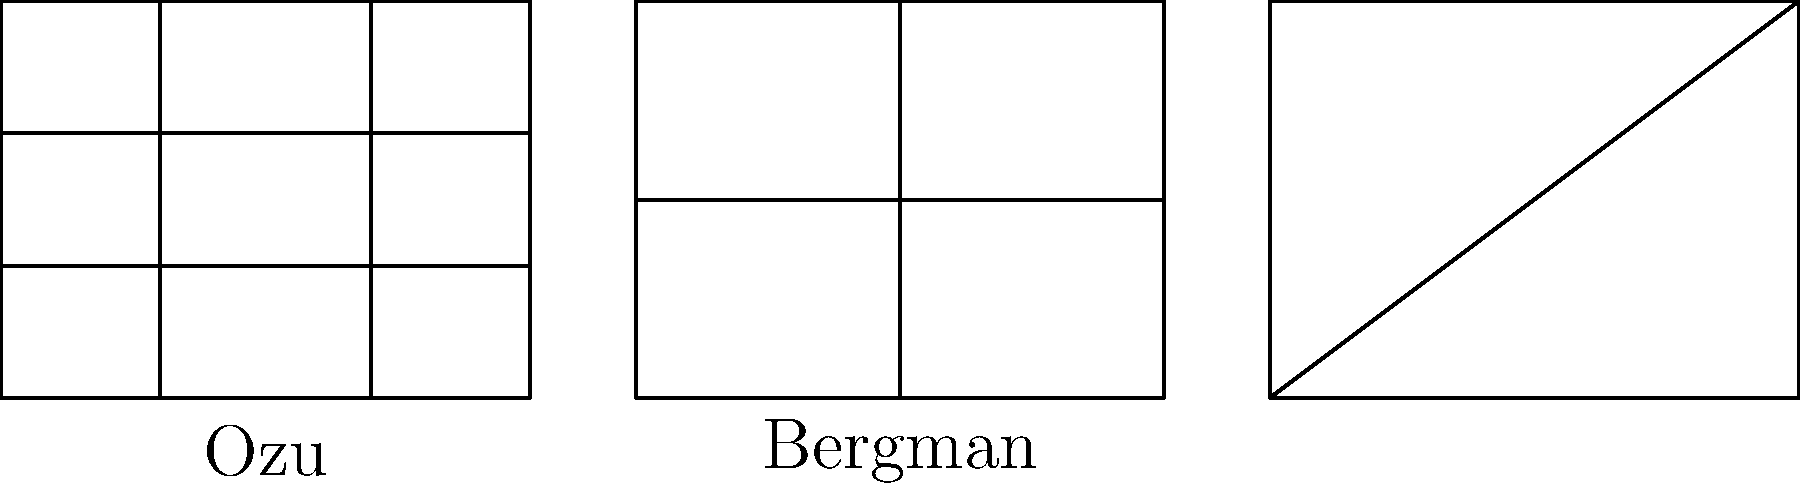Analyze the frame compositions illustrated above, which represent the distinctive styles of three influential foreign directors. Which director is known for using a "tatami shot" perspective, often dividing the frame into precise geometric sections as shown in the first diagram? To answer this question, let's break down the characteristics of each frame composition:

1. The first frame is divided into a 3x3 grid, creating nine equal sections. This precise geometric division is characteristic of the "tatami shot" perspective, named after the traditional Japanese floor mats. This style is strongly associated with Yasujirō Ozu, a renowned Japanese director.

2. The second frame is divided into two vertical sections and two horizontal sections, creating a more balanced and symmetrical composition. This style is often used by Ingmar Bergman, a Swedish director known for his focus on psychological and existential themes.

3. The third frame features diagonal lines intersecting at the center, creating a dynamic and tension-filled composition. This style is often employed by Andrei Tarkovsky, a Russian director known for his long takes and spiritual themes.

Among these three directors, Yasujirō Ozu is the one famously known for using the "tatami shot" perspective. This low-angle shot, typically about 50 cm (20 inches) above floor level, corresponds to the eye-level of a person kneeling on a tatami mat. Ozu often combined this with precise geometric framing, as shown in the first diagram.

This style allowed Ozu to create a sense of intimacy and stillness in his films, reflecting traditional Japanese aesthetics and the rhythm of everyday life. It became one of his most recognizable techniques, influencing many filmmakers worldwide.
Answer: Yasujirō Ozu 